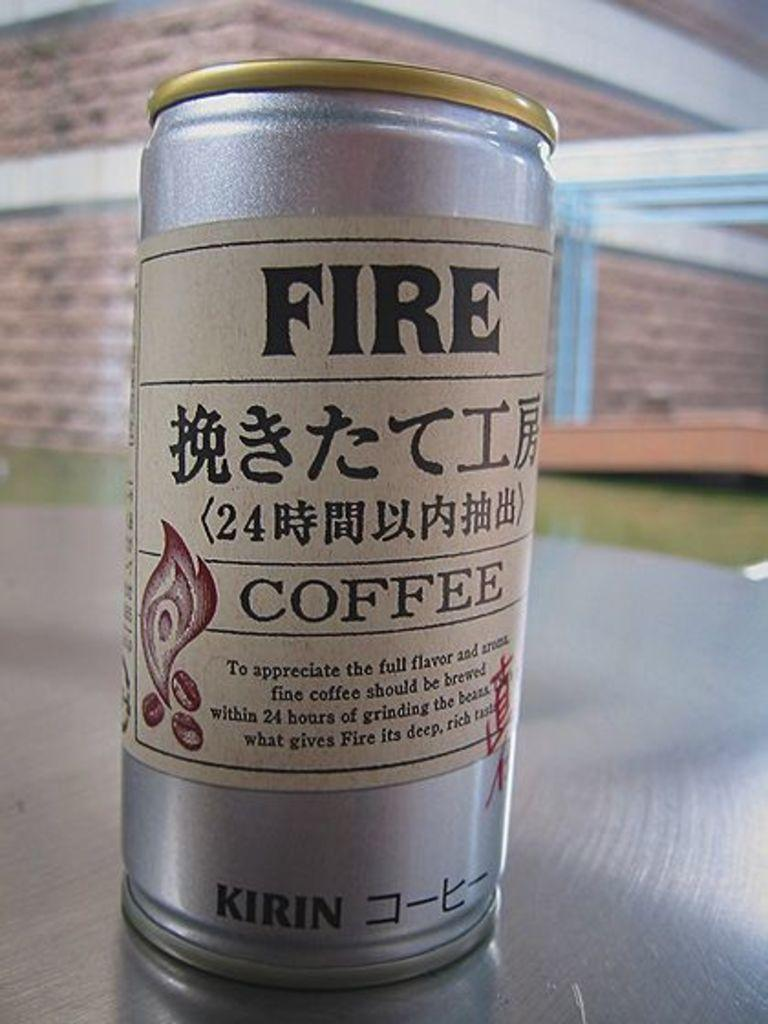Provide a one-sentence caption for the provided image. A silver can of Fire coffee by Kirin is placed on a table. 